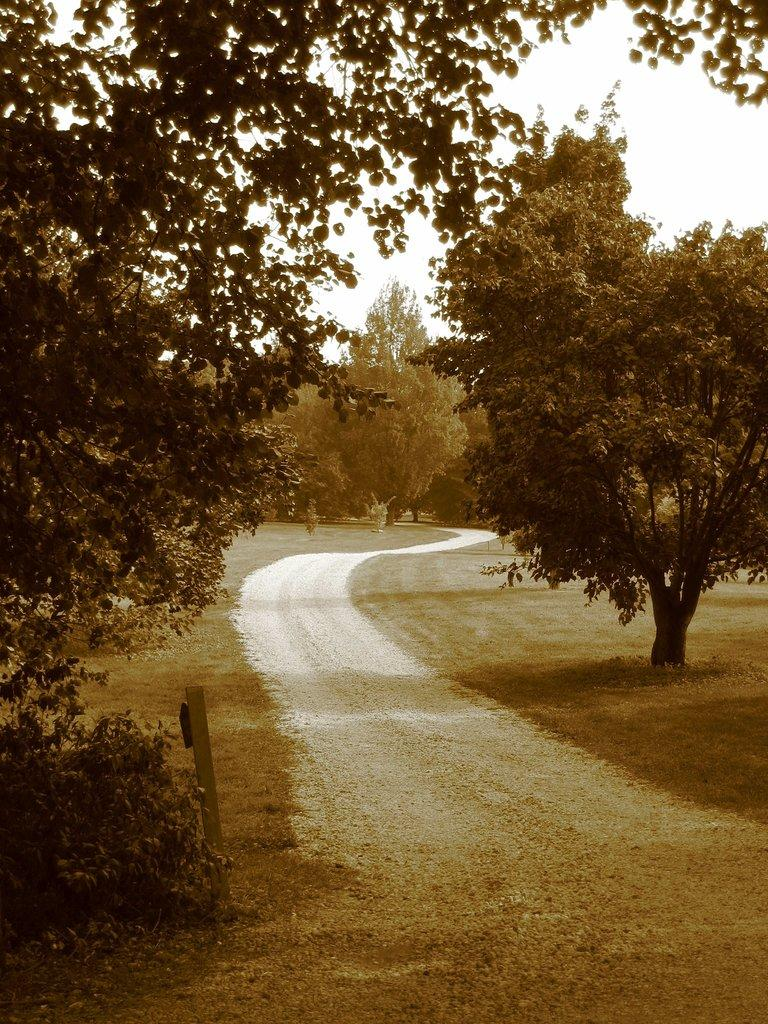What is the main feature of the image? There is a road in the image. What can be seen beside the road? There are trees, plants, and grass beside the road. What is visible at the top of the image? The sky is visible at the top of the image. What type of straw is used to decorate the part of the road in the image? There is no straw or decoration present on the road in the image. 